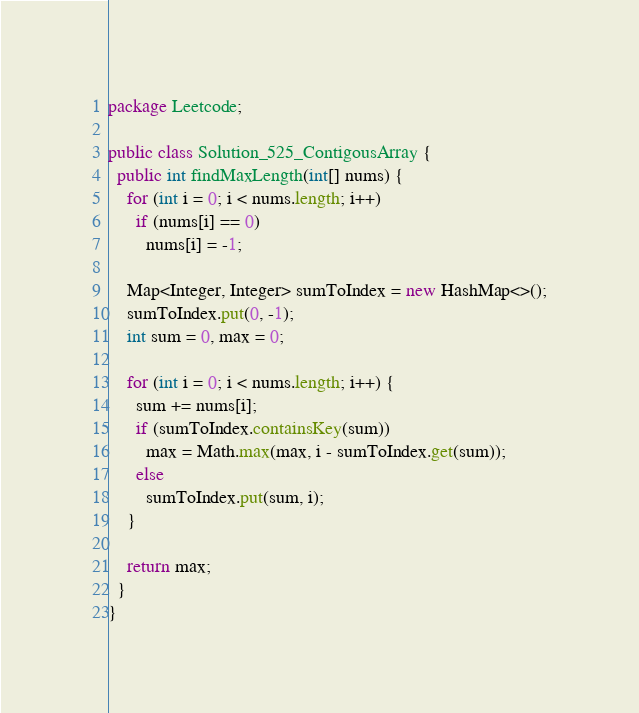<code> <loc_0><loc_0><loc_500><loc_500><_Java_>package Leetcode;

public class Solution_525_ContigousArray {
  public int findMaxLength(int[] nums) {
    for (int i = 0; i < nums.length; i++)
      if (nums[i] == 0)
        nums[i] = -1;

    Map<Integer, Integer> sumToIndex = new HashMap<>();
    sumToIndex.put(0, -1);
    int sum = 0, max = 0;

    for (int i = 0; i < nums.length; i++) {
      sum += nums[i];
      if (sumToIndex.containsKey(sum))
        max = Math.max(max, i - sumToIndex.get(sum));
      else
        sumToIndex.put(sum, i);
    }

    return max;
  }
}
</code> 